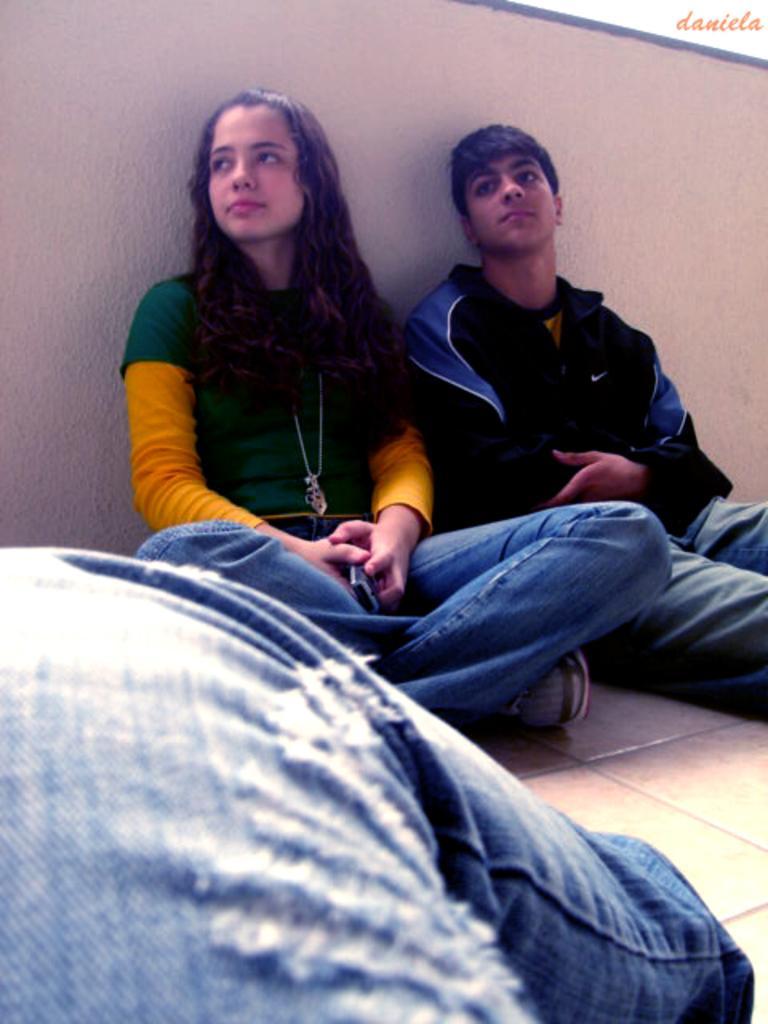Can you describe this image briefly? In this picture we can see a person's leg, two people are sitting on the floor and in the background we can see the wall. 